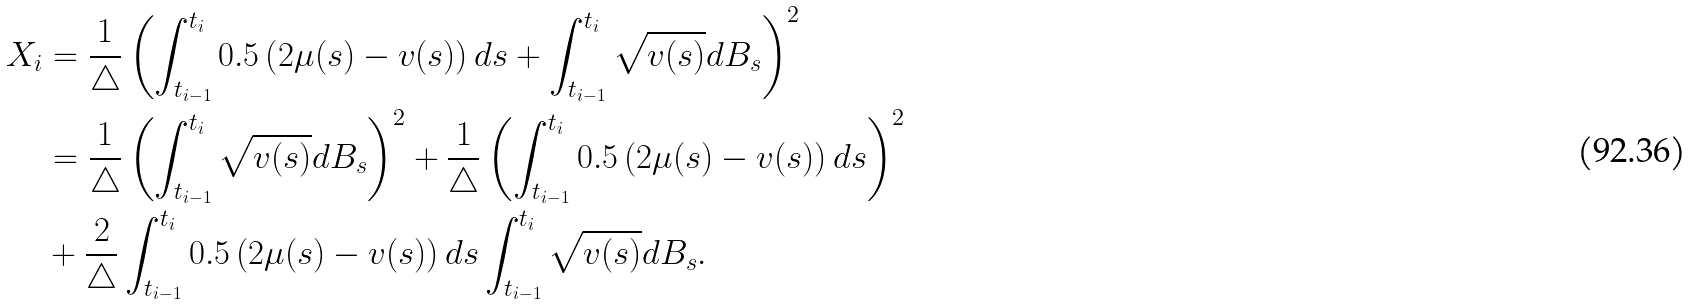Convert formula to latex. <formula><loc_0><loc_0><loc_500><loc_500>X _ { i } & = \frac { 1 } { \triangle } \left ( \int _ { t _ { i - 1 } } ^ { t _ { i } } 0 . 5 \left ( 2 \mu ( s ) - v ( s ) \right ) d s + \int _ { t _ { i - 1 } } ^ { t _ { i } } \sqrt { v ( s ) } d B _ { s } \right ) ^ { 2 } \\ & = \frac { 1 } { \triangle } \left ( \int _ { t _ { i - 1 } } ^ { t _ { i } } \sqrt { v ( s ) } d B _ { s } \right ) ^ { 2 } + \frac { 1 } { \triangle } \left ( \int _ { t _ { i - 1 } } ^ { t _ { i } } 0 . 5 \left ( 2 \mu ( s ) - v ( s ) \right ) d s \right ) ^ { 2 } \\ & + \frac { 2 } { \triangle } \int _ { t _ { i - 1 } } ^ { t _ { i } } 0 . 5 \left ( 2 \mu ( s ) - v ( s ) \right ) d s \int _ { t _ { i - 1 } } ^ { t _ { i } } \sqrt { v ( s ) } d B _ { s } .</formula> 